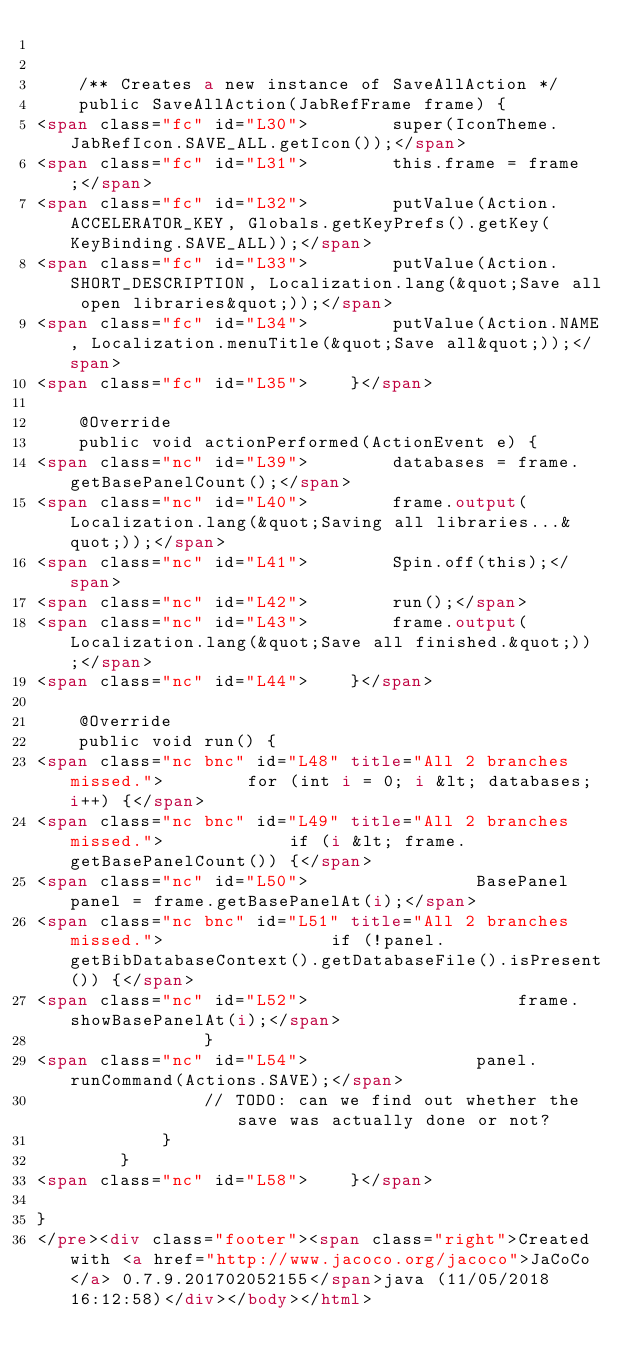Convert code to text. <code><loc_0><loc_0><loc_500><loc_500><_HTML_>

    /** Creates a new instance of SaveAllAction */
    public SaveAllAction(JabRefFrame frame) {
<span class="fc" id="L30">        super(IconTheme.JabRefIcon.SAVE_ALL.getIcon());</span>
<span class="fc" id="L31">        this.frame = frame;</span>
<span class="fc" id="L32">        putValue(Action.ACCELERATOR_KEY, Globals.getKeyPrefs().getKey(KeyBinding.SAVE_ALL));</span>
<span class="fc" id="L33">        putValue(Action.SHORT_DESCRIPTION, Localization.lang(&quot;Save all open libraries&quot;));</span>
<span class="fc" id="L34">        putValue(Action.NAME, Localization.menuTitle(&quot;Save all&quot;));</span>
<span class="fc" id="L35">    }</span>

    @Override
    public void actionPerformed(ActionEvent e) {
<span class="nc" id="L39">        databases = frame.getBasePanelCount();</span>
<span class="nc" id="L40">        frame.output(Localization.lang(&quot;Saving all libraries...&quot;));</span>
<span class="nc" id="L41">        Spin.off(this);</span>
<span class="nc" id="L42">        run();</span>
<span class="nc" id="L43">        frame.output(Localization.lang(&quot;Save all finished.&quot;));</span>
<span class="nc" id="L44">    }</span>

    @Override
    public void run() {
<span class="nc bnc" id="L48" title="All 2 branches missed.">        for (int i = 0; i &lt; databases; i++) {</span>
<span class="nc bnc" id="L49" title="All 2 branches missed.">            if (i &lt; frame.getBasePanelCount()) {</span>
<span class="nc" id="L50">                BasePanel panel = frame.getBasePanelAt(i);</span>
<span class="nc bnc" id="L51" title="All 2 branches missed.">                if (!panel.getBibDatabaseContext().getDatabaseFile().isPresent()) {</span>
<span class="nc" id="L52">                    frame.showBasePanelAt(i);</span>
                }
<span class="nc" id="L54">                panel.runCommand(Actions.SAVE);</span>
                // TODO: can we find out whether the save was actually done or not?
            }
        }
<span class="nc" id="L58">    }</span>

}
</pre><div class="footer"><span class="right">Created with <a href="http://www.jacoco.org/jacoco">JaCoCo</a> 0.7.9.201702052155</span>java (11/05/2018 16:12:58)</div></body></html></code> 